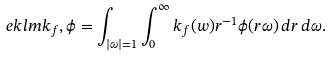Convert formula to latex. <formula><loc_0><loc_0><loc_500><loc_500>\ e k l m { k _ { f } , \phi } = \int _ { | \omega | = 1 } \int ^ { \infty } _ { 0 } k _ { f } ( w ) r ^ { - 1 } \phi ( r \omega ) \, d r \, d \omega .</formula> 